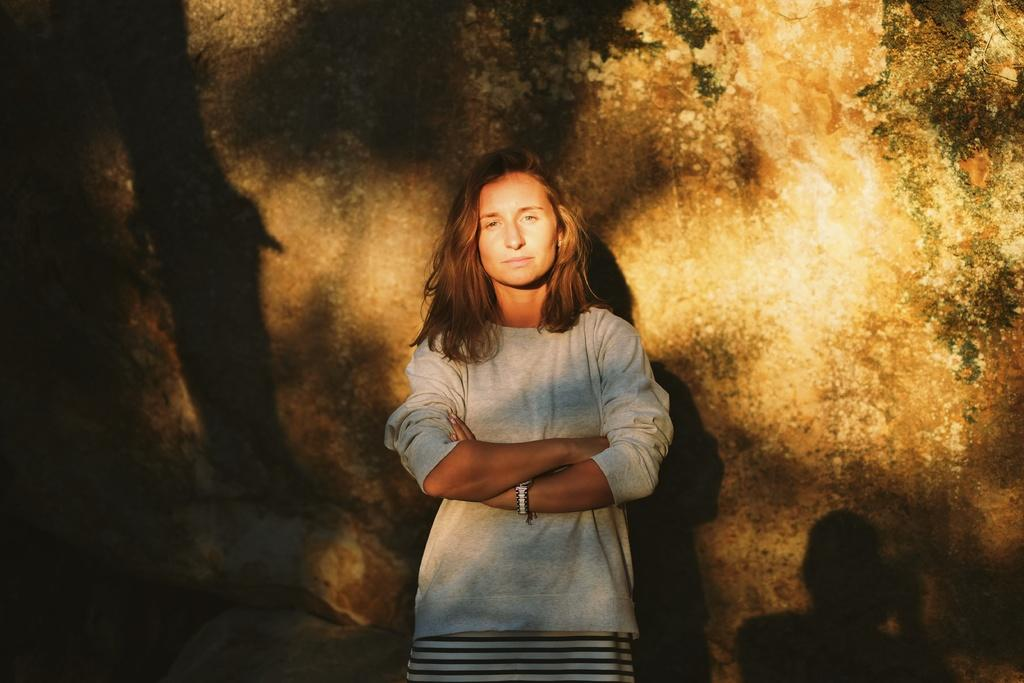Who is present in the image? There is a woman in the image. What is the woman doing in the image? The woman is standing in the image. What expression does the woman have in the image? The woman is smiling in the image. What can be seen in the background of the image? There is a wall in the background of the image. Reasoning: Let's think step by step by step in order to produce the conversation. We start by identifying the main subject in the image, which is the woman. Then, we describe her actions and expression, as well as the background of the image. Each question is designed to elicit a specific detail about the image that is known from the provided facts. Absurd Question/Answer: What type of honey can be seen dripping from the lamp in the image? There is no lamp or honey present in the image. What kind of waves can be seen in the background of the image? There are no waves visible in the image; only a wall is present in the background. What type of honey can be seen dripping from the lamp in the image? There is no lamp or honey present in the image. What kind of waves can be seen in the background of the image? There are no waves visible in the image; only a wall is present in the background. 